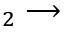<formula> <loc_0><loc_0><loc_500><loc_500>_ { 2 } \longrightarrow</formula> 